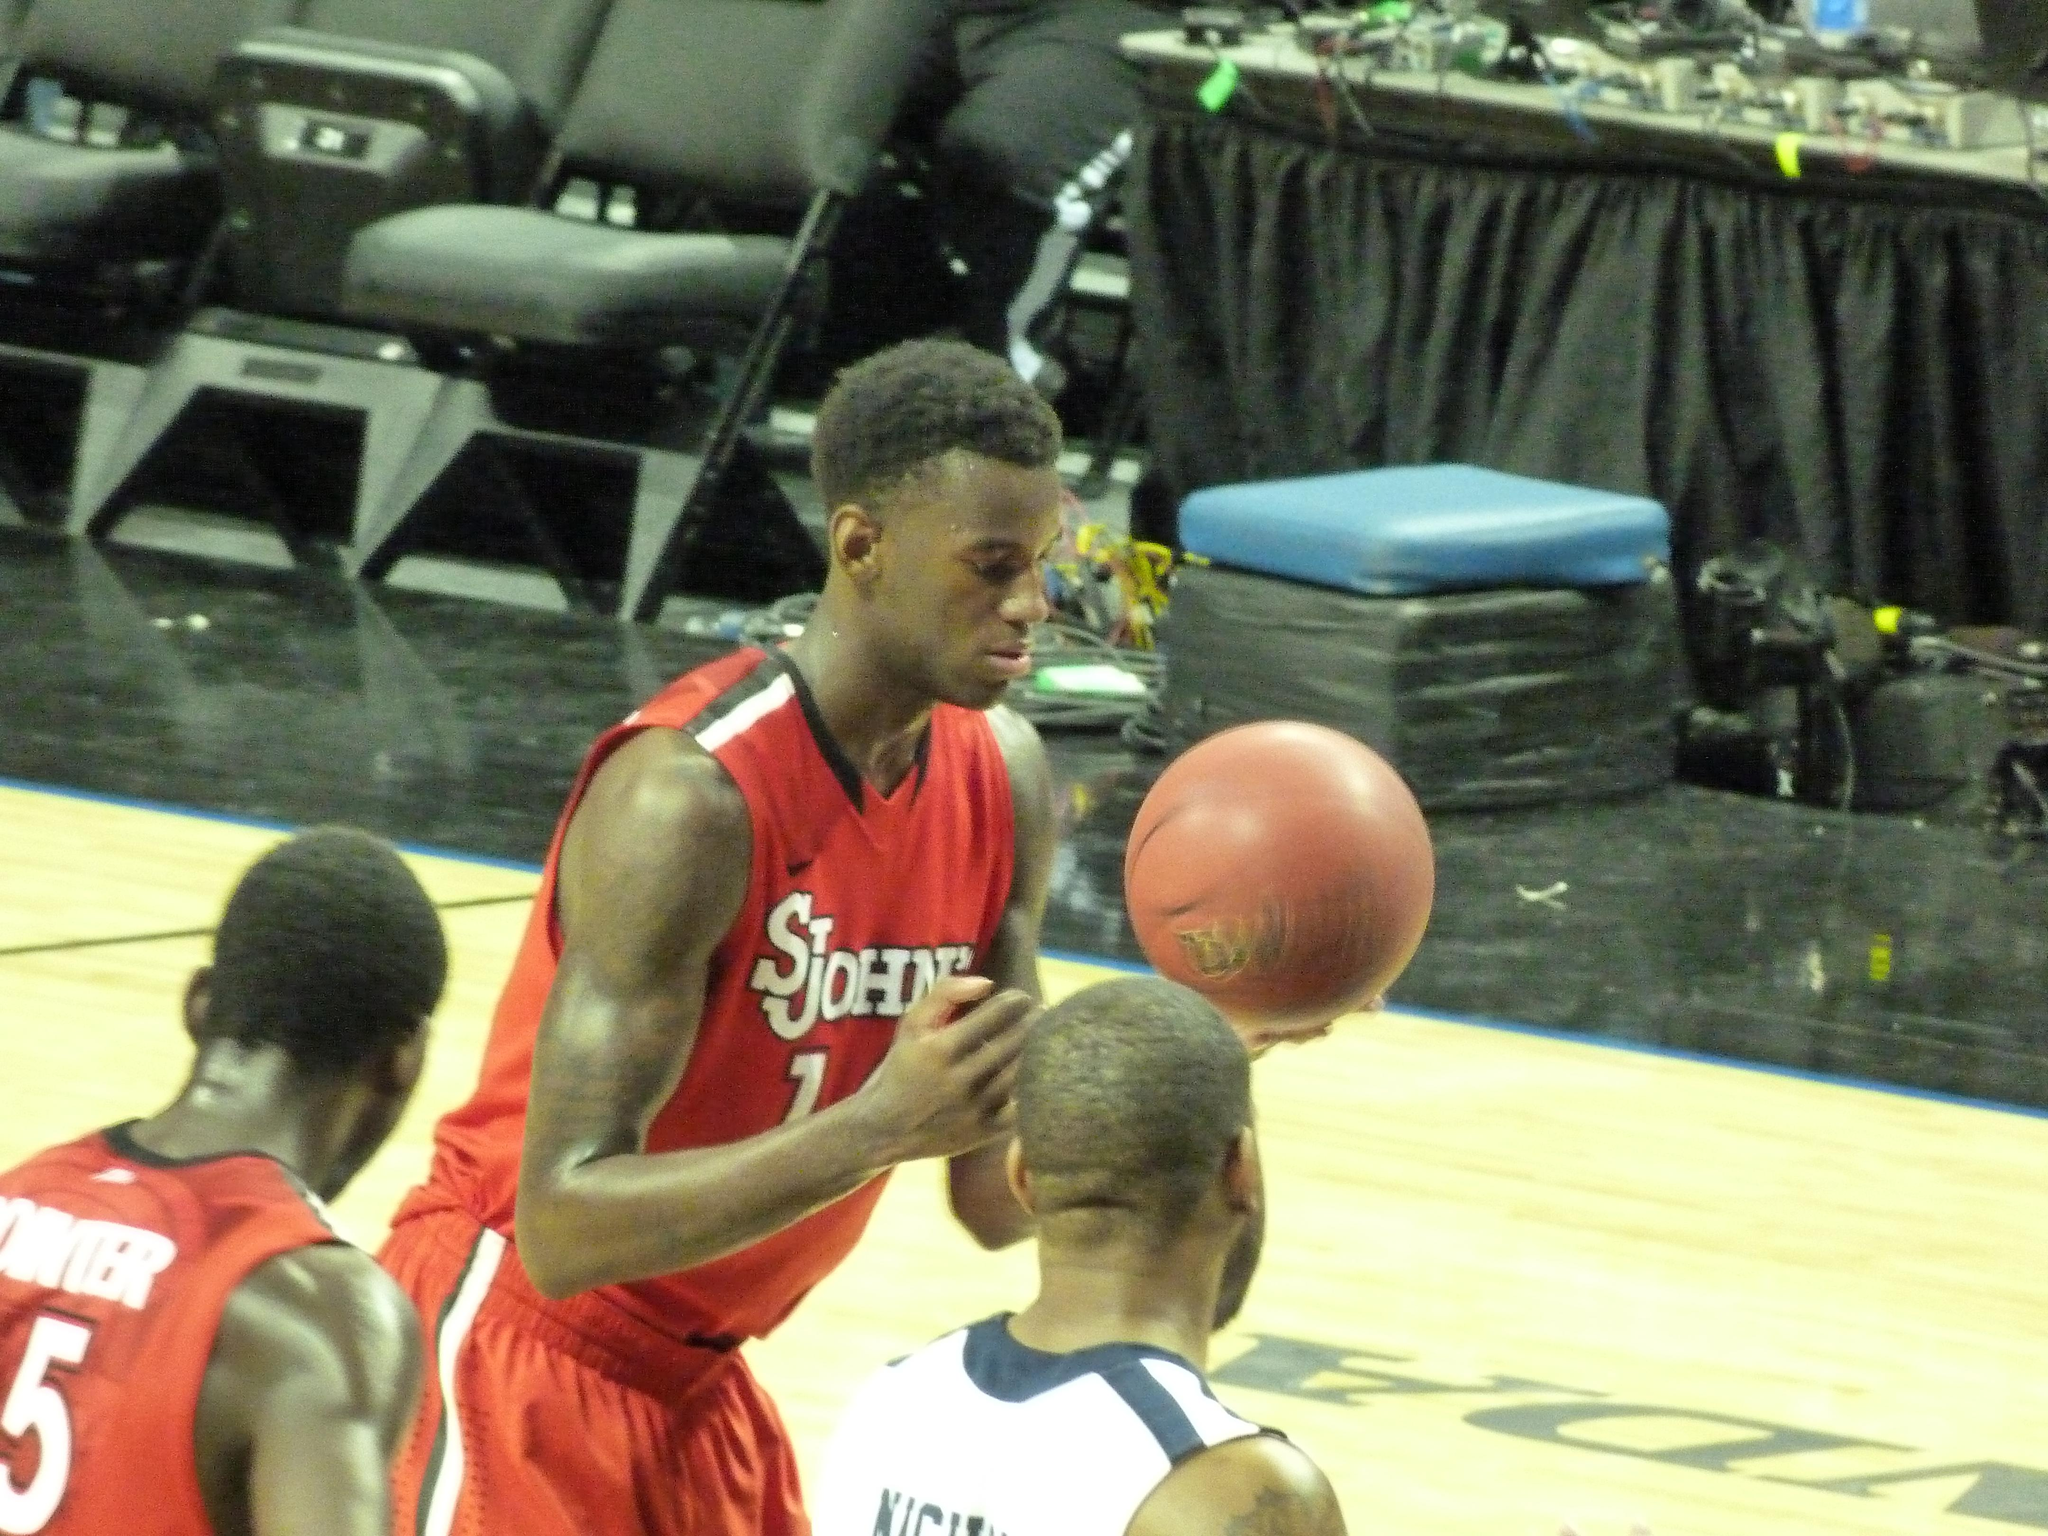How many people are present in the image? There are three people in the image. What object can be seen in the image besides the people? There is a ball in the image. What is visible beneath the people and the ball? The ground is visible in the image. What can be seen in the background of the image? There are chairs and some objects in the background of the image. What type of art can be seen on the trucks in the image? There are no trucks present in the image, so it is not possible to determine what type of art might be on them. 